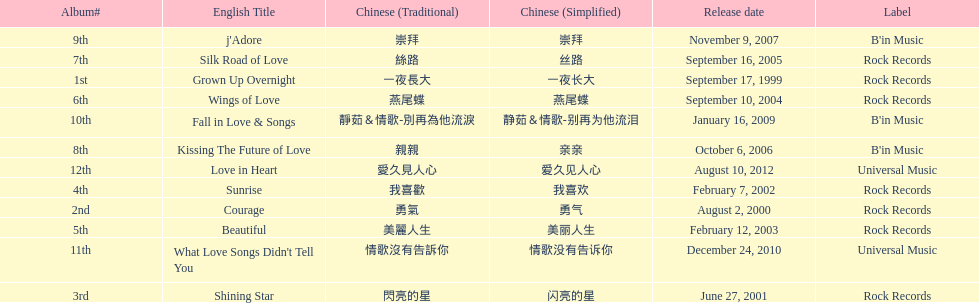Which was the only album to be released by b'in music in an even-numbered year? Kissing The Future of Love. 